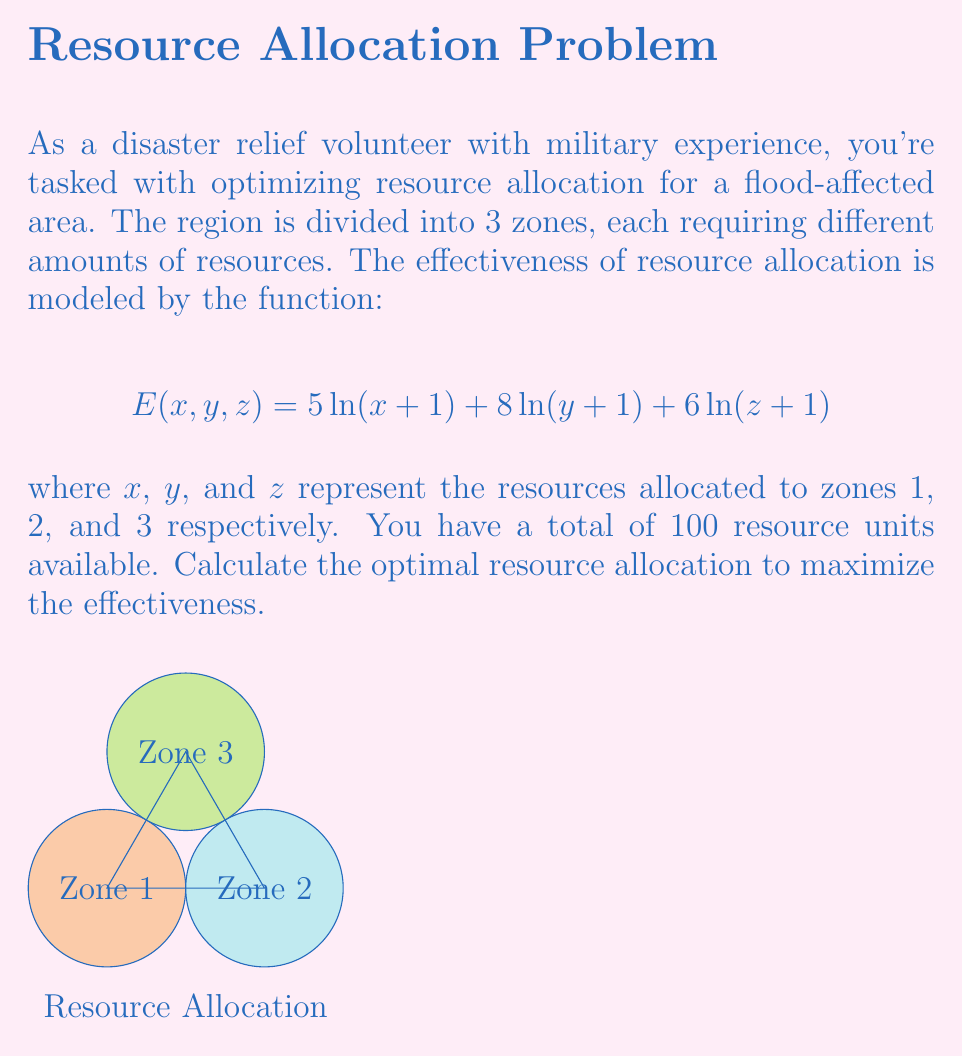Solve this math problem. To solve this problem, we'll use the method of Lagrange multipliers:

1) Define the Lagrangian function:
   $$L(x,y,z,\lambda) = 5\ln(x+1) + 8\ln(y+1) + 6\ln(z+1) - \lambda(x+y+z-100)$$

2) Set partial derivatives to zero:
   $$\frac{\partial L}{\partial x} = \frac{5}{x+1} - \lambda = 0$$
   $$\frac{\partial L}{\partial y} = \frac{8}{y+1} - \lambda = 0$$
   $$\frac{\partial L}{\partial z} = \frac{6}{z+1} - \lambda = 0$$
   $$\frac{\partial L}{\partial \lambda} = x + y + z - 100 = 0$$

3) From these equations, we can deduce:
   $$\frac{5}{x+1} = \frac{8}{y+1} = \frac{6}{z+1} = \lambda$$

4) This implies:
   $$x+1 = \frac{5}{\lambda}, y+1 = \frac{8}{\lambda}, z+1 = \frac{6}{\lambda}$$

5) Substituting into the constraint equation:
   $$(\frac{5}{\lambda}-1) + (\frac{8}{\lambda}-1) + (\frac{6}{\lambda}-1) = 100$$
   $$\frac{19}{\lambda} - 3 = 100$$
   $$\frac{19}{\lambda} = 103$$
   $$\lambda = \frac{19}{103}$$

6) Now we can solve for x, y, and z:
   $$x = \frac{5}{\lambda} - 1 = \frac{5 \cdot 103}{19} - 1 \approx 26.11$$
   $$y = \frac{8}{\lambda} - 1 = \frac{8 \cdot 103}{19} - 1 \approx 42.37$$
   $$z = \frac{6}{\lambda} - 1 = \frac{6 \cdot 103}{19} - 1 \approx 31.53$$

7) Rounding to the nearest whole number (as we can't allocate partial resources):
   x ≈ 26, y ≈ 42, z ≈ 32
Answer: Zone 1: 26 units, Zone 2: 42 units, Zone 3: 32 units 